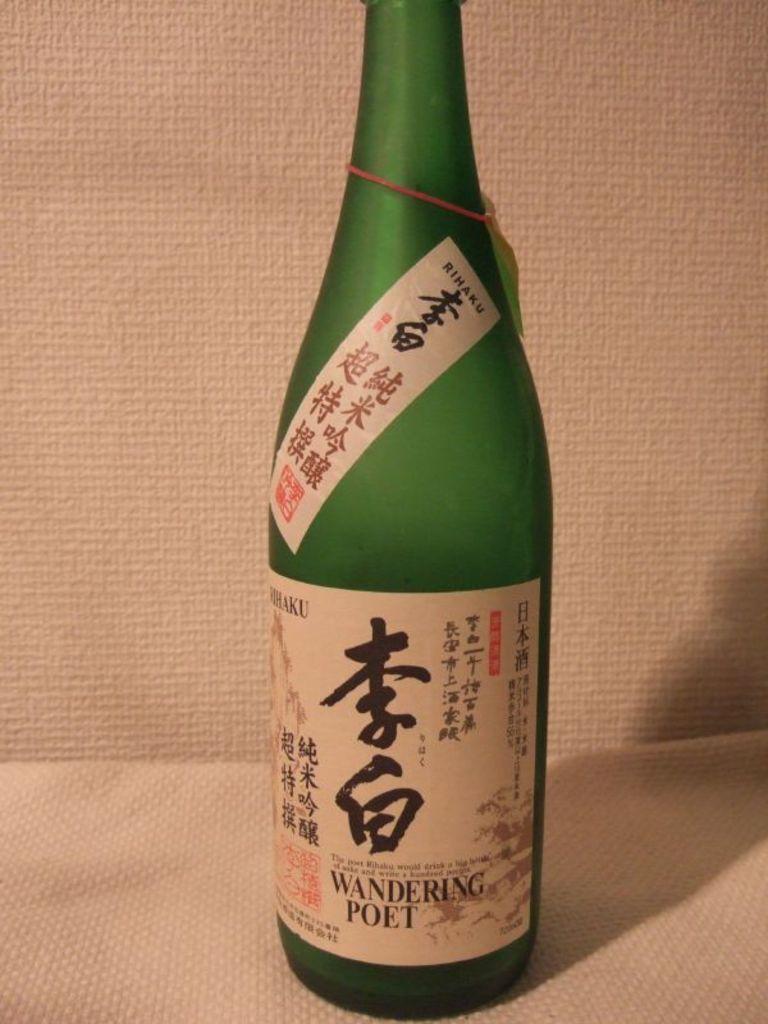What brand is the alcohol?
Provide a short and direct response. Wandering poet. 